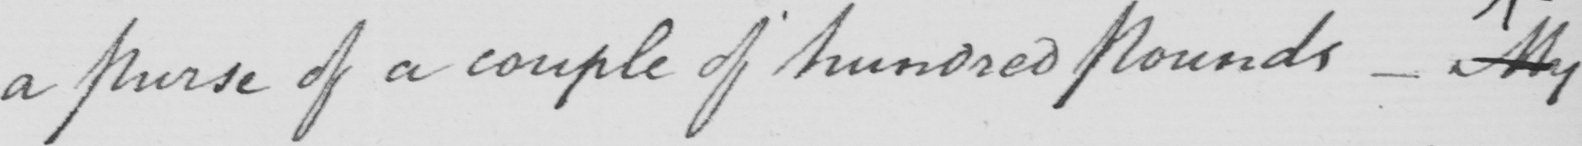Can you read and transcribe this handwriting? a Purse of a couple of hundred pounds  _  My 